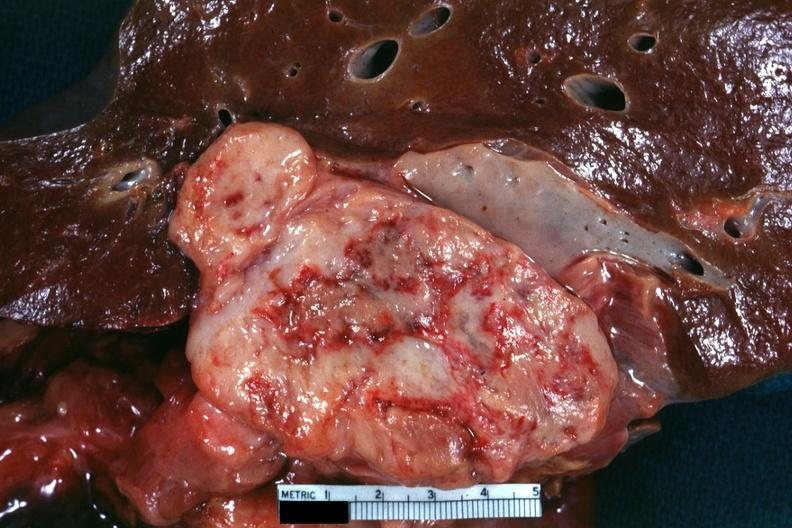s acute peritonitis present?
Answer the question using a single word or phrase. No 